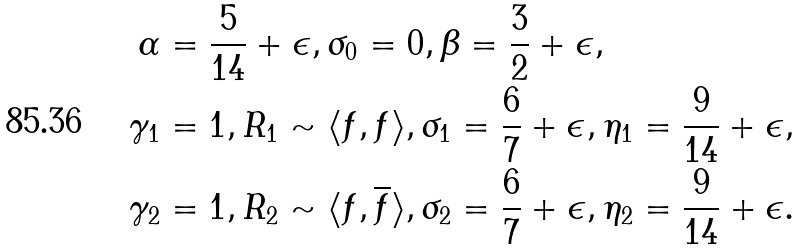Convert formula to latex. <formula><loc_0><loc_0><loc_500><loc_500>\alpha & = \frac { 5 } { 1 4 } + \epsilon , \sigma _ { 0 } = 0 , \beta = \frac { 3 } { 2 } + \epsilon , \\ \gamma _ { 1 } & = 1 , R _ { 1 } \sim \langle f , f \rangle , \sigma _ { 1 } = \frac { 6 } { 7 } + \epsilon , \eta _ { 1 } = \frac { 9 } { 1 4 } + \epsilon , \\ \gamma _ { 2 } & = 1 , R _ { 2 } \sim \langle f , \overline { f } \rangle , \sigma _ { 2 } = \frac { 6 } { 7 } + \epsilon , \eta _ { 2 } = \frac { 9 } { 1 4 } + \epsilon .</formula> 